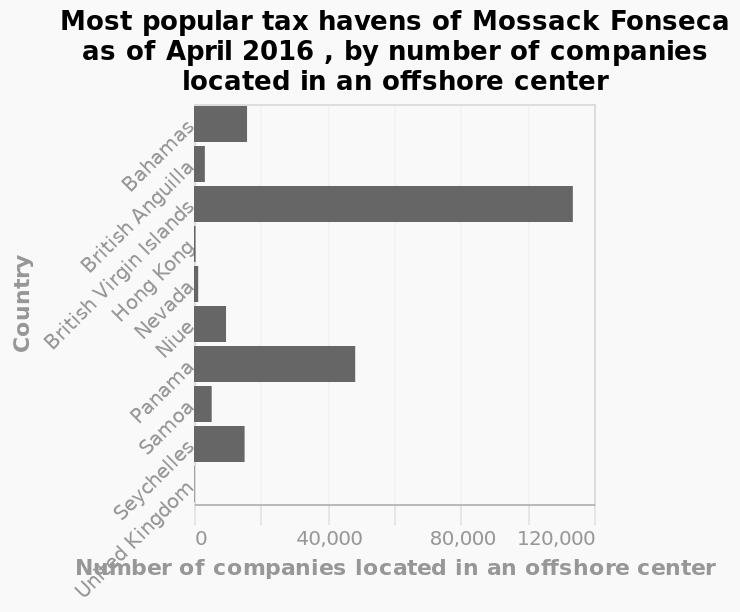<image>
Are there any tax havens in the United Kingdom for Mossack Fonseca? No, there are none in the United Kingdom. How popular is the British Virgin Isles as a tax haven for Mossack Fonseca? The British Virgin Isles is by far the most popular tax haven for Mossack Fonseca. please summary the statistics and relations of the chart The most popular tax haven for Mossack Fonseca is the British Virgin Isles by a long way. There are none in the United Kingdom. 